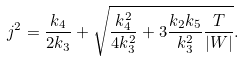<formula> <loc_0><loc_0><loc_500><loc_500>j ^ { 2 } = \frac { k _ { 4 } } { 2 k _ { 3 } } + \sqrt { \frac { k _ { 4 } ^ { 2 } } { 4 k _ { 3 } ^ { 2 } } + 3 \frac { k _ { 2 } k _ { 5 } } { k _ { 3 } ^ { 2 } } \frac { T } { | W | } } .</formula> 